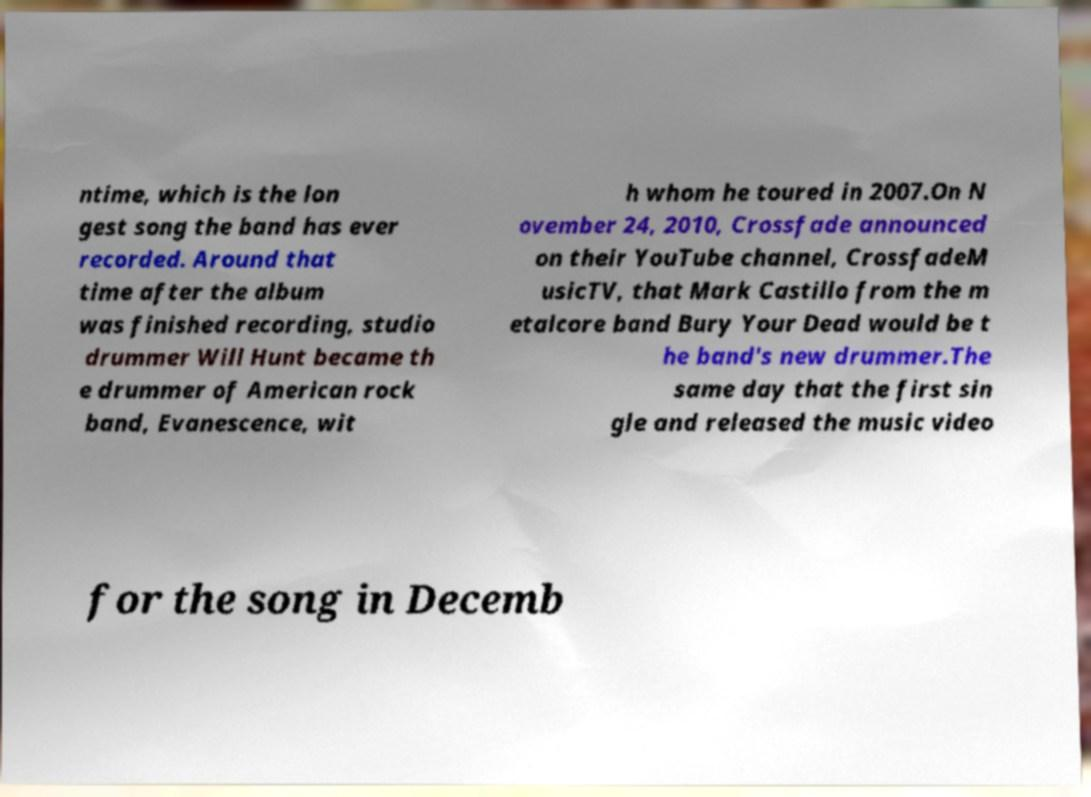Please read and relay the text visible in this image. What does it say? ntime, which is the lon gest song the band has ever recorded. Around that time after the album was finished recording, studio drummer Will Hunt became th e drummer of American rock band, Evanescence, wit h whom he toured in 2007.On N ovember 24, 2010, Crossfade announced on their YouTube channel, CrossfadeM usicTV, that Mark Castillo from the m etalcore band Bury Your Dead would be t he band's new drummer.The same day that the first sin gle and released the music video for the song in Decemb 